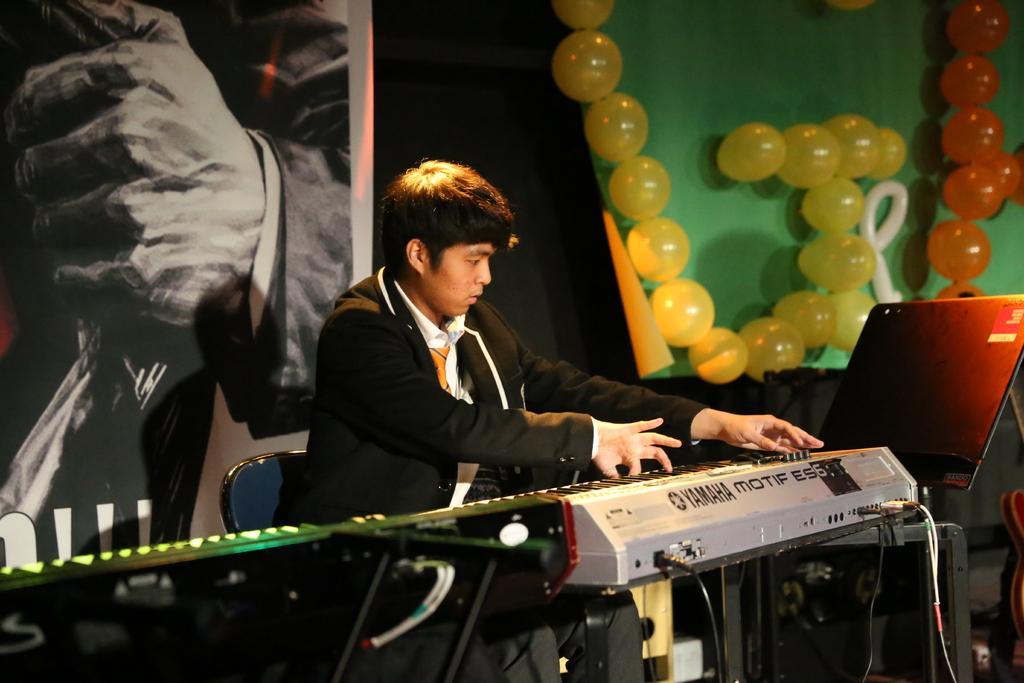How would you summarize this image in a sentence or two? In the image there is a boy playing piano and on the background wall there is painting and balloons on it. 